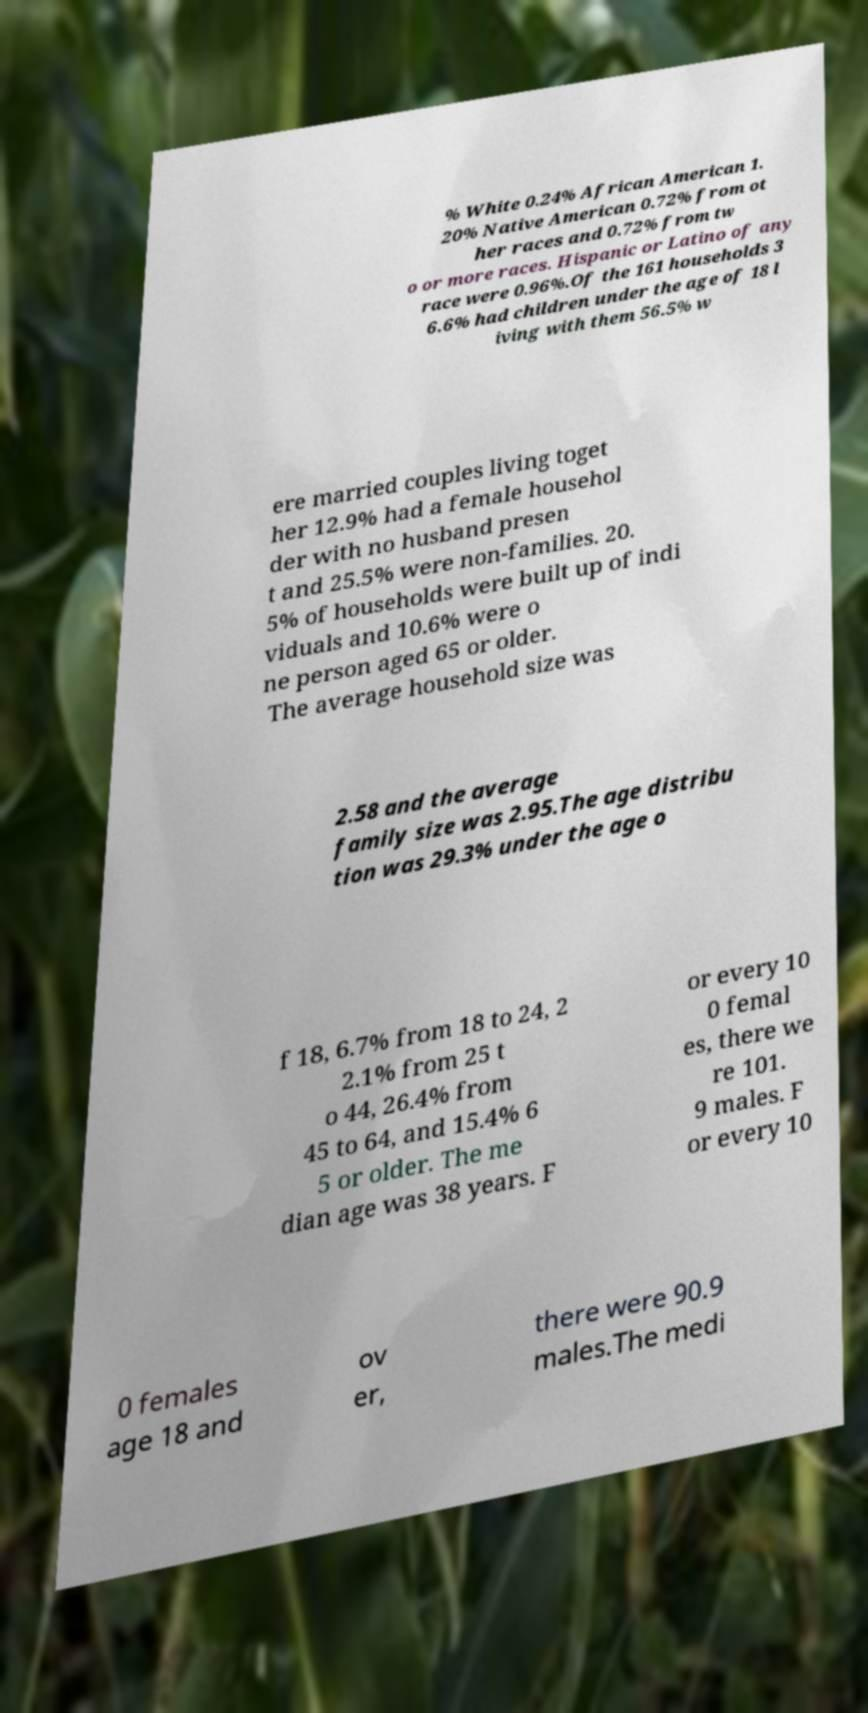There's text embedded in this image that I need extracted. Can you transcribe it verbatim? % White 0.24% African American 1. 20% Native American 0.72% from ot her races and 0.72% from tw o or more races. Hispanic or Latino of any race were 0.96%.Of the 161 households 3 6.6% had children under the age of 18 l iving with them 56.5% w ere married couples living toget her 12.9% had a female househol der with no husband presen t and 25.5% were non-families. 20. 5% of households were built up of indi viduals and 10.6% were o ne person aged 65 or older. The average household size was 2.58 and the average family size was 2.95.The age distribu tion was 29.3% under the age o f 18, 6.7% from 18 to 24, 2 2.1% from 25 t o 44, 26.4% from 45 to 64, and 15.4% 6 5 or older. The me dian age was 38 years. F or every 10 0 femal es, there we re 101. 9 males. F or every 10 0 females age 18 and ov er, there were 90.9 males.The medi 